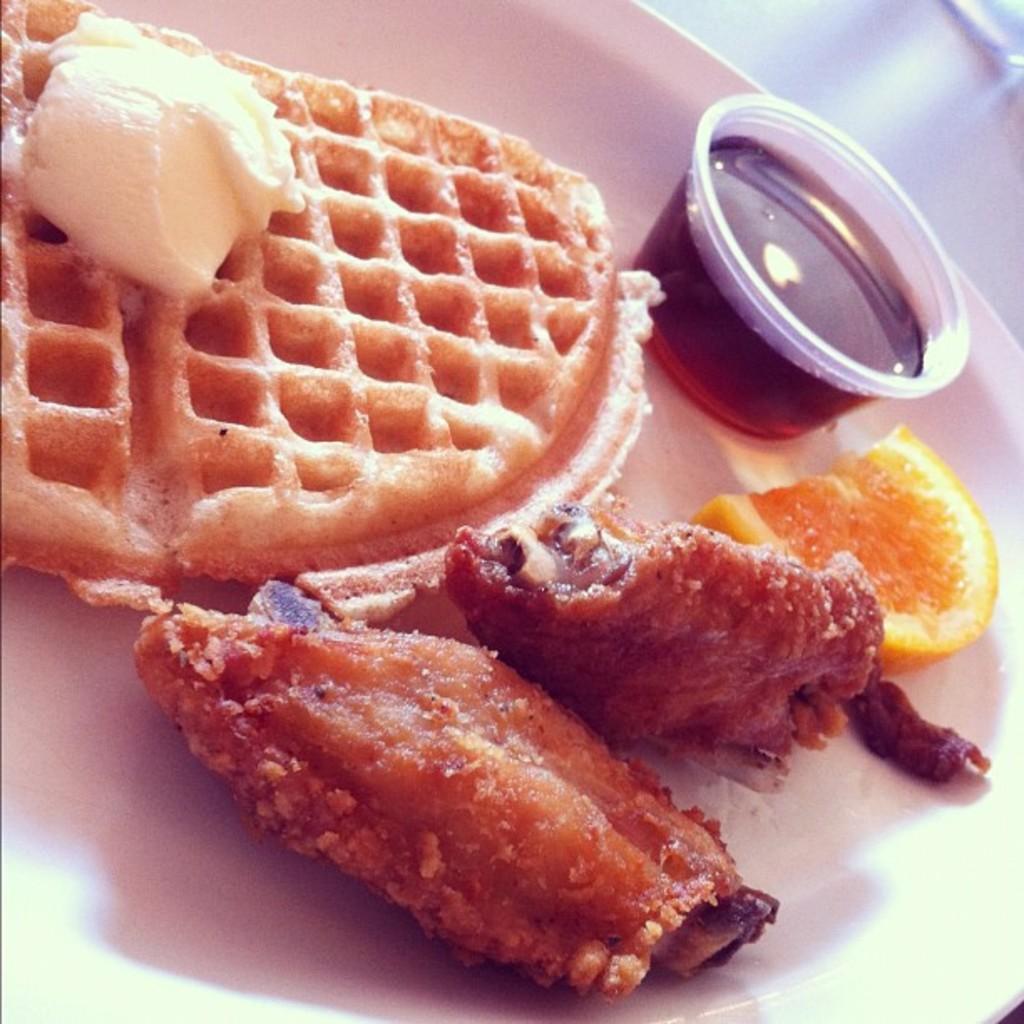Can you describe this image briefly? In this image I can see a food items on the white color plate. I can see a bowl. The food is in white,brown and orange color. 